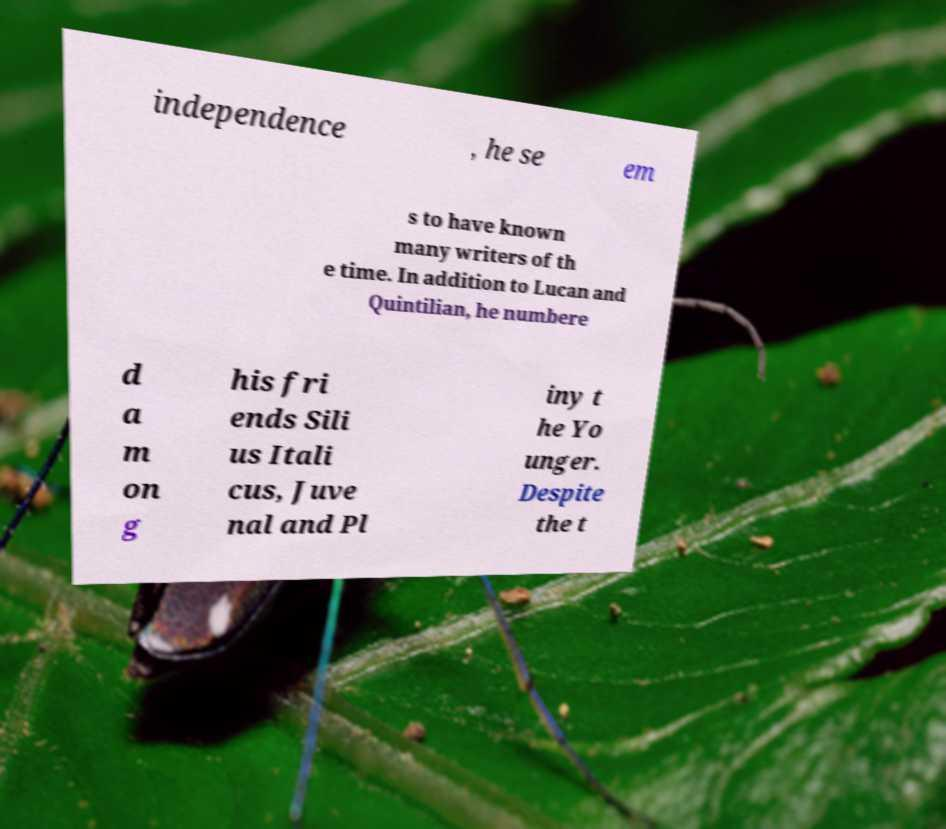Please identify and transcribe the text found in this image. independence , he se em s to have known many writers of th e time. In addition to Lucan and Quintilian, he numbere d a m on g his fri ends Sili us Itali cus, Juve nal and Pl iny t he Yo unger. Despite the t 